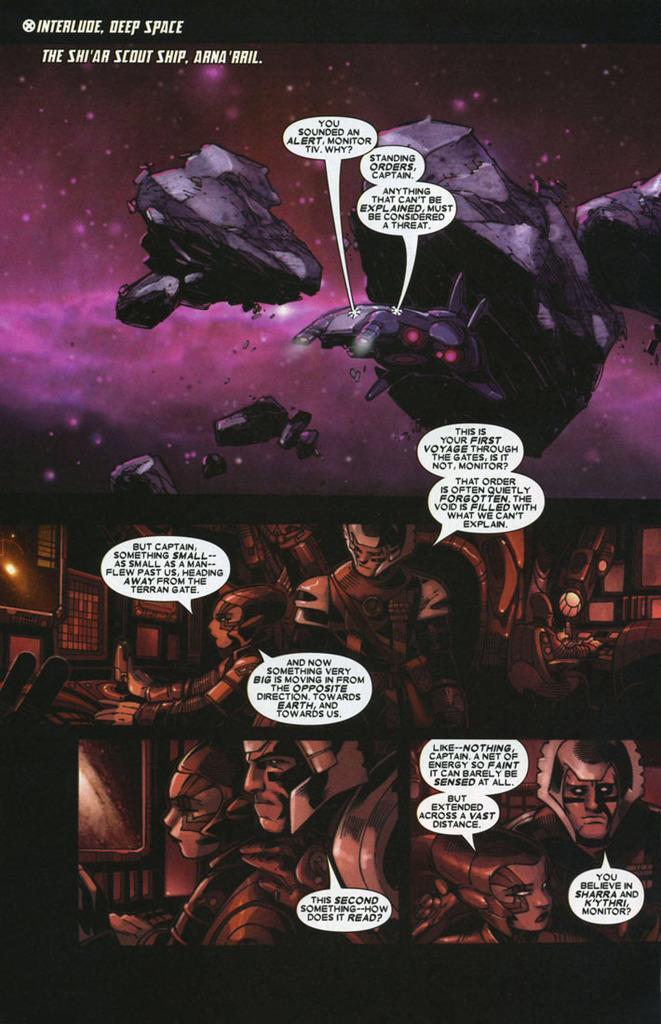Could you give a brief overview of what you see in this image? In this image we can see animated pictures and some text was written on them. 